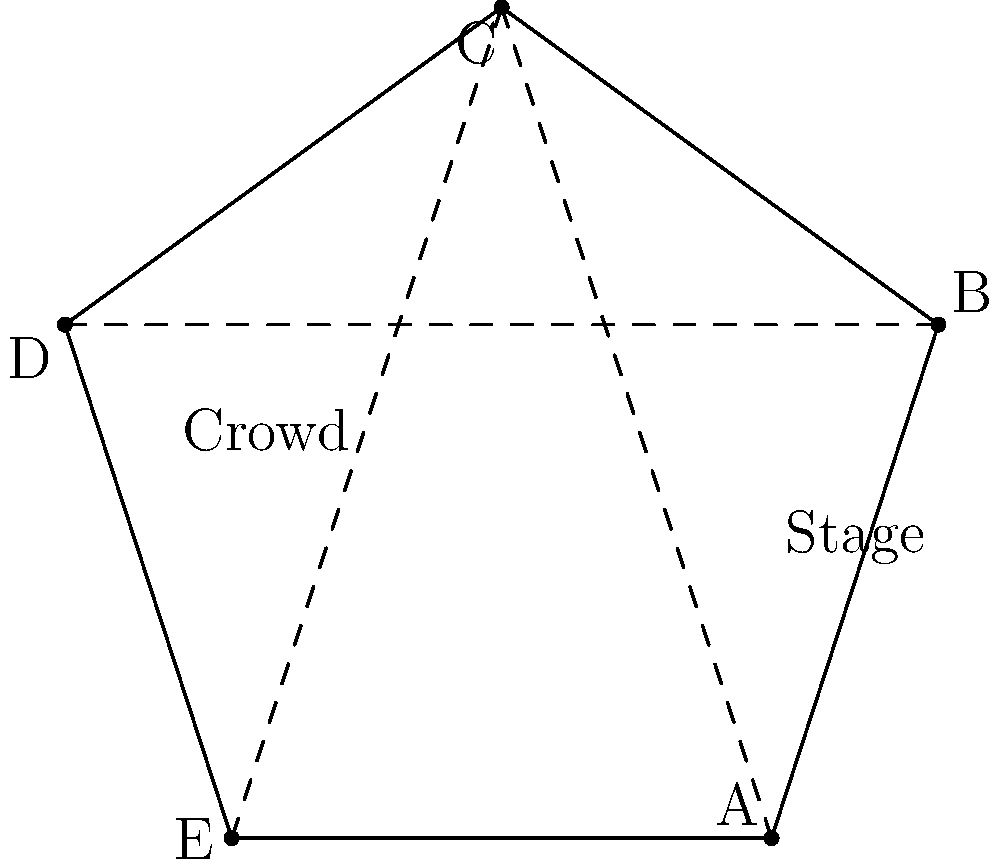In the pentagonal rally venue shown above, which strategic placement of barriers (represented by dashed lines) would create the illusion of a larger crowd size when viewed from the stage area? To create the illusion of a larger crowd size, we need to consider the following steps:

1. Identify the stage area: The stage is located at the top of the pentagon, between points A and B.

2. Understand crowd perception: The appearance of crowd size is influenced by depth and density. A crowd that appears deeper and denser will seem larger.

3. Analyze barrier placements:
   a. A-C: This barrier would create a triangular area, reducing visible space.
   b. B-D: Similar to A-C, this would also reduce visible space.
   c. C-E: This barrier would create two sections, potentially increasing perceived depth.

4. Consider optical illusions: The C-E barrier placement creates a forced perspective, making the back of the crowd appear further away.

5. Evaluate crowd management: The C-E barrier allows for better crowd control and easier movement of supporters to fill gaps.

6. Assess camera angles: The C-E barrier provides the best opportunity for camera placement to capture a seemingly endless crowd.

7. Compare to alternatives: Other barrier placements would create smaller, more confined spaces that could make the crowd appear smaller.

Therefore, the C-E barrier placement is the most effective for creating the illusion of a larger crowd size when viewed from the stage area.
Answer: C-E barrier 